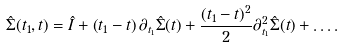<formula> <loc_0><loc_0><loc_500><loc_500>\hat { \Sigma } ( t _ { 1 } , t ) = \hat { I } + \left ( t _ { 1 } - t \right ) \partial _ { t _ { 1 } } \hat { \Sigma } ( t ) + \frac { ( t _ { 1 } - t ) ^ { 2 } } { 2 } \partial ^ { 2 } _ { t _ { 1 } } \hat { \Sigma } ( t ) + \dots .</formula> 